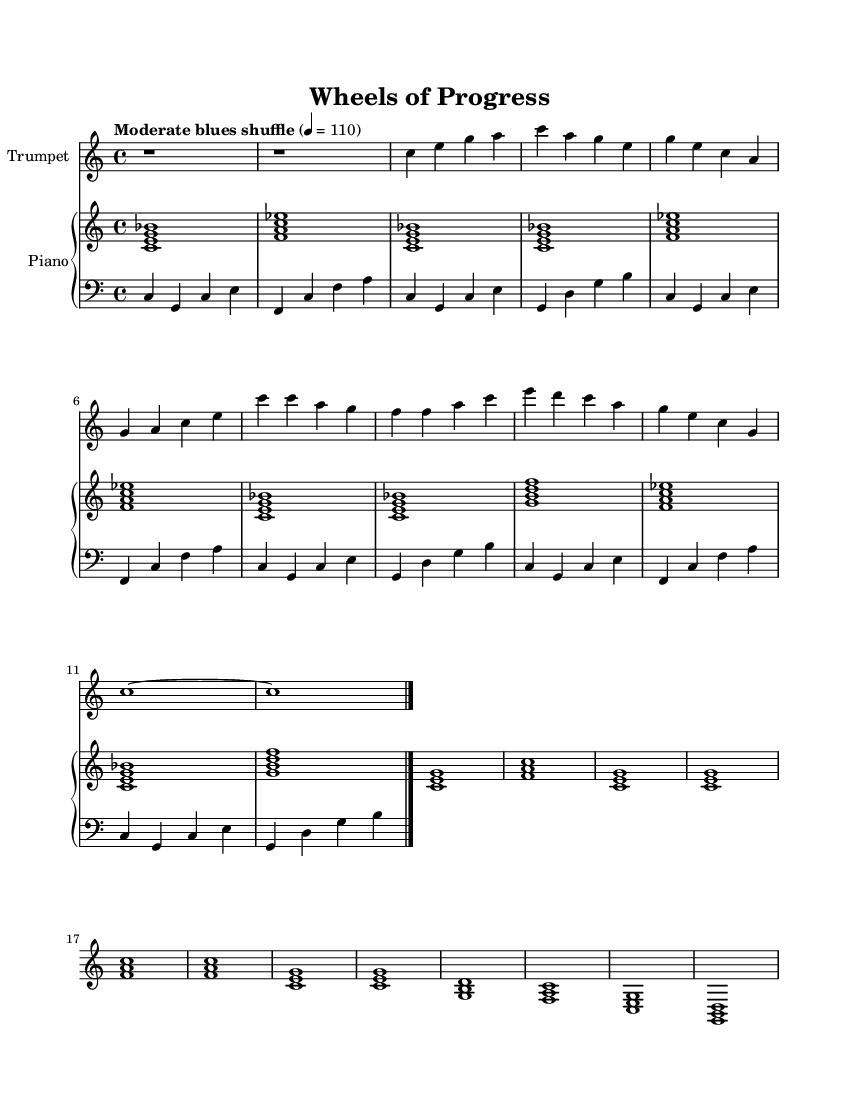What is the key signature of this music? The key signature is C major, which has no sharps or flats.
Answer: C major What is the time signature of this piece? The time signature is indicated as 4/4, which means there are four beats in each measure.
Answer: 4/4 What is the tempo marking of the music? The tempo marking given is "Moderate blues shuffle," indicating a relaxed swing feel, with a specific metronome marking of 110 beats per minute.
Answer: Moderate blues shuffle How many measures are in the chorus section? The chorus section consists of four measures, as can be counted from the notation shown.
Answer: 4 What type of chord is played in the first measure? The chord in the first measure is a C7 chord, which is used prominently in jazz and blues music.
Answer: C7 What instrument plays the melody in this piece? The melody is primarily played by the trumpet, as it is labeled in the score.
Answer: Trumpet How does the bass line correspond to the chords? The bass line outlines the fundamental notes of the chords, typically playing the root followed by the fifth, which is common in jazz.
Answer: Root and fifth 